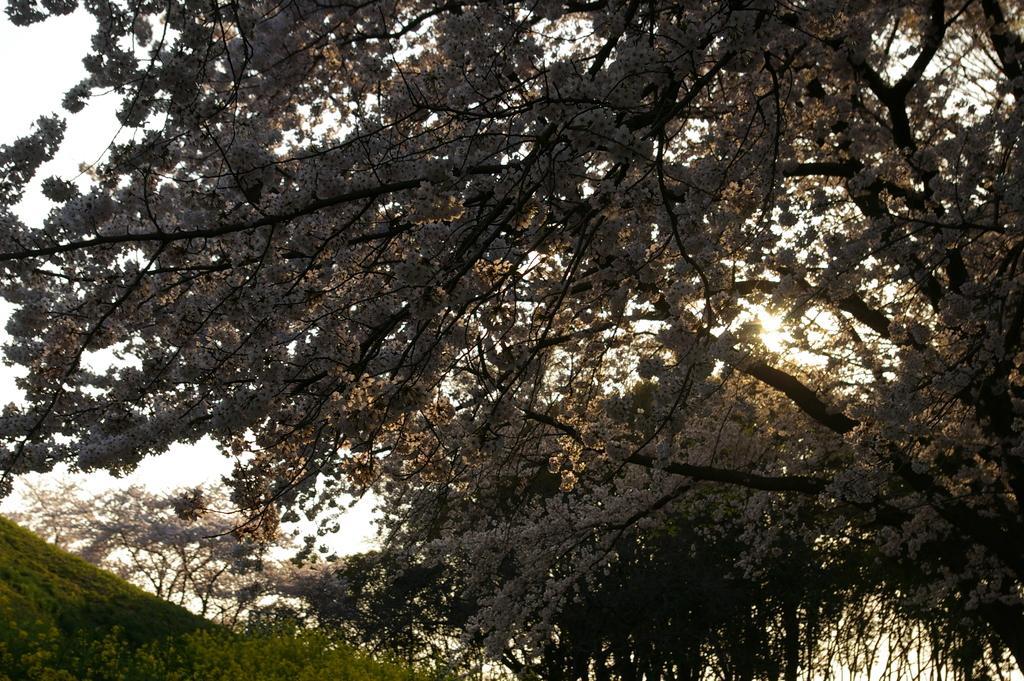Describe this image in one or two sentences. In this image we can see trees, flowers, sky, hill and plants. 